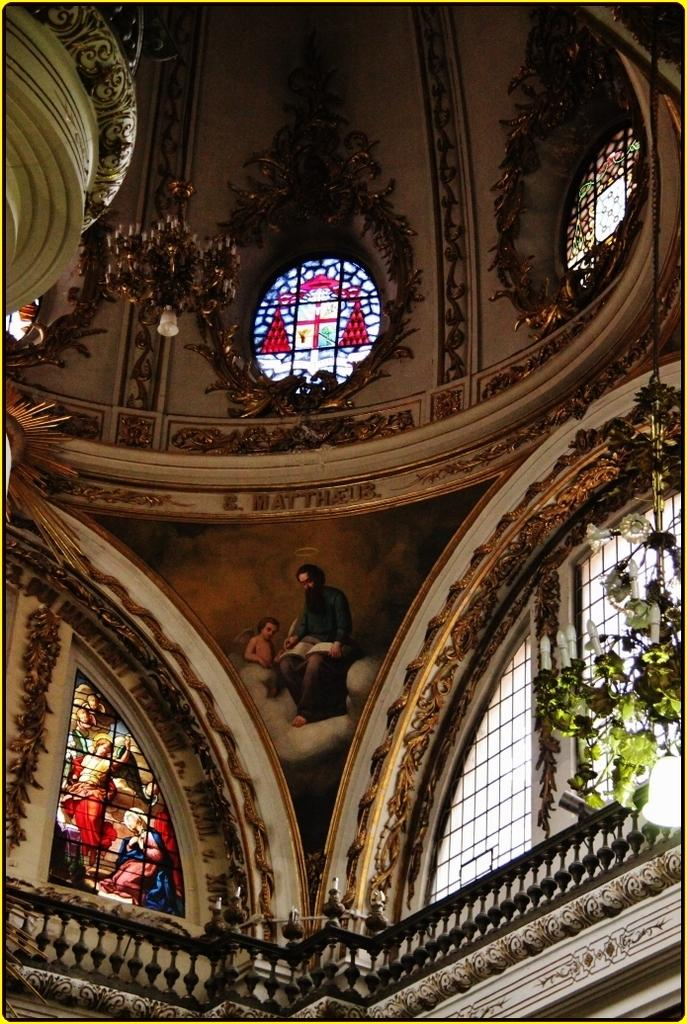What is located in the center of the image? There are windows in the center of the image. What can be seen on the right side of the image? There are leaves on the right side of the image. What is hanging at the top of the image? There is a chandelier hanging at the top of the image. What is depicted on the windows? Images of persons are present on the windows. Can you tell me how many zippers are visible on the chandelier in the image? There are no zippers present on the chandelier in the image. What type of band is playing music in the image? There is no band present in the image. 